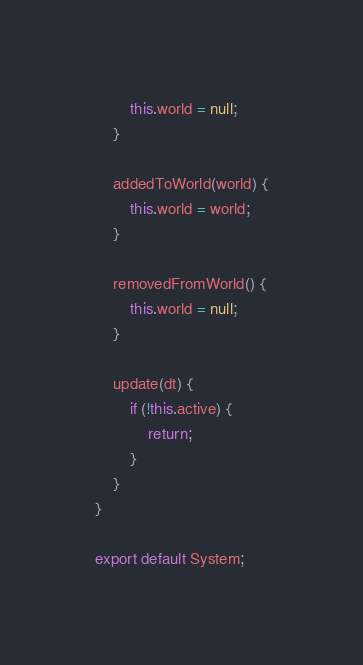Convert code to text. <code><loc_0><loc_0><loc_500><loc_500><_JavaScript_>        this.world = null;
    }

    addedToWorld(world) {
        this.world = world;
    }

    removedFromWorld() {
        this.world = null;
    }

    update(dt) {
        if (!this.active) {
            return;
        }
    }
}

export default System;
</code> 